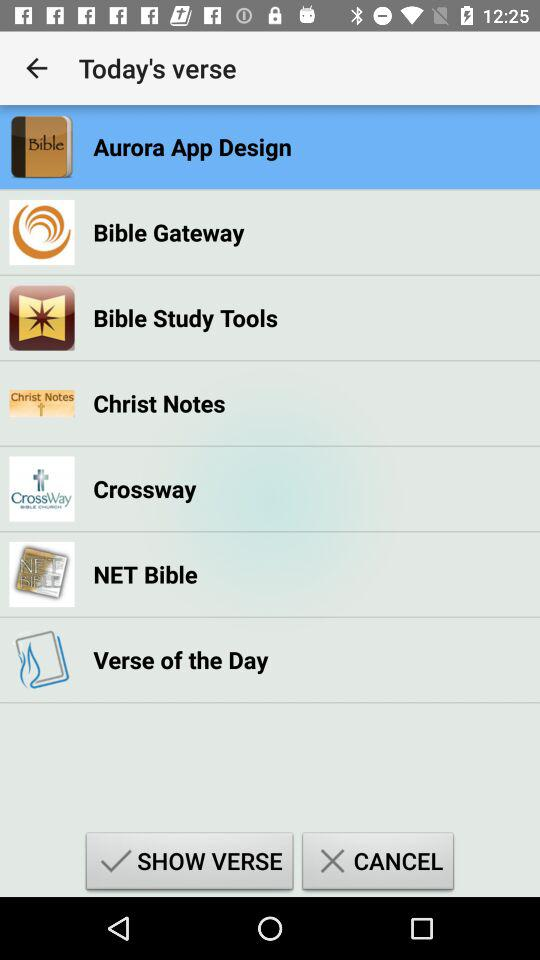Which option is selected? The selected option is "Aurora App Design". 